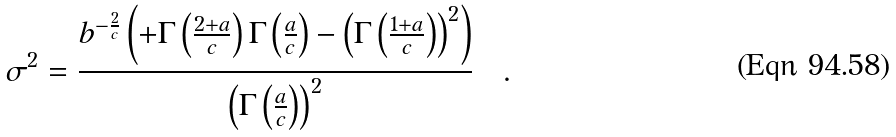Convert formula to latex. <formula><loc_0><loc_0><loc_500><loc_500>\sigma ^ { 2 } = \frac { { b } ^ { - \frac { 2 } { c } } \left ( + \Gamma \left ( { \frac { 2 + a } { c } } \right ) \Gamma \left ( { \frac { a } { c } } \right ) - \left ( \Gamma \left ( { \frac { 1 + a } { c } } \right ) \right ) ^ { 2 } \right ) } { \left ( \Gamma \left ( { \frac { a } { c } } \right ) \right ) ^ { 2 } } \quad .</formula> 